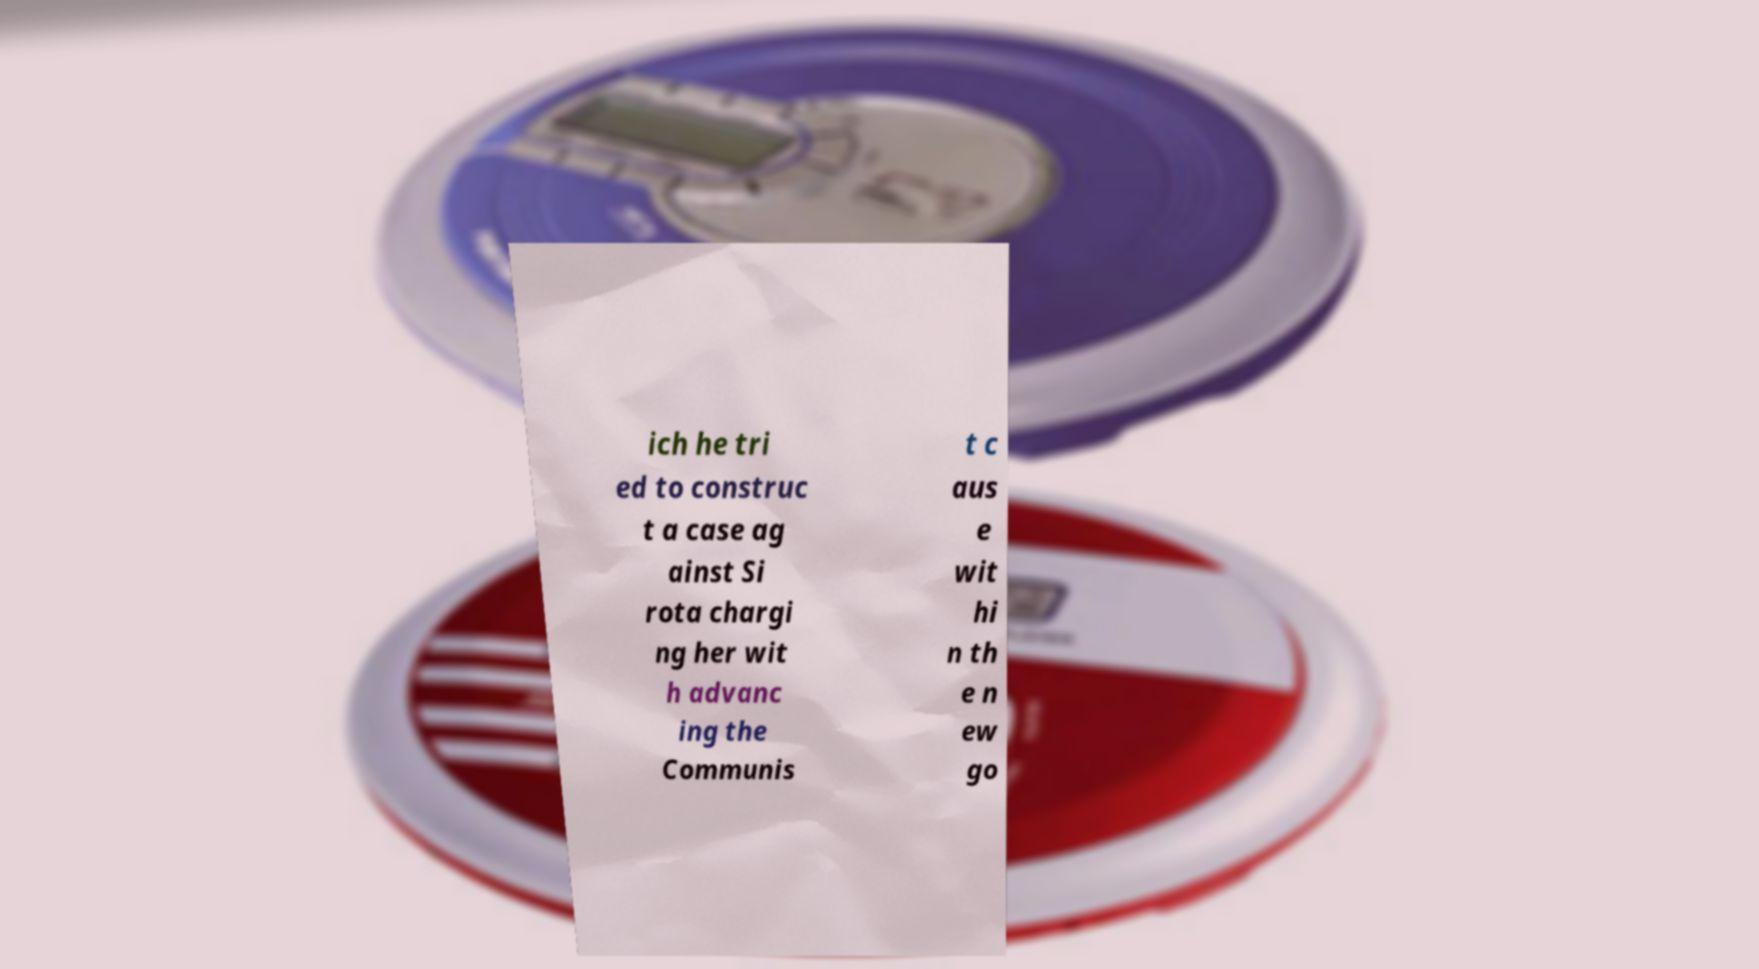Please identify and transcribe the text found in this image. ich he tri ed to construc t a case ag ainst Si rota chargi ng her wit h advanc ing the Communis t c aus e wit hi n th e n ew go 